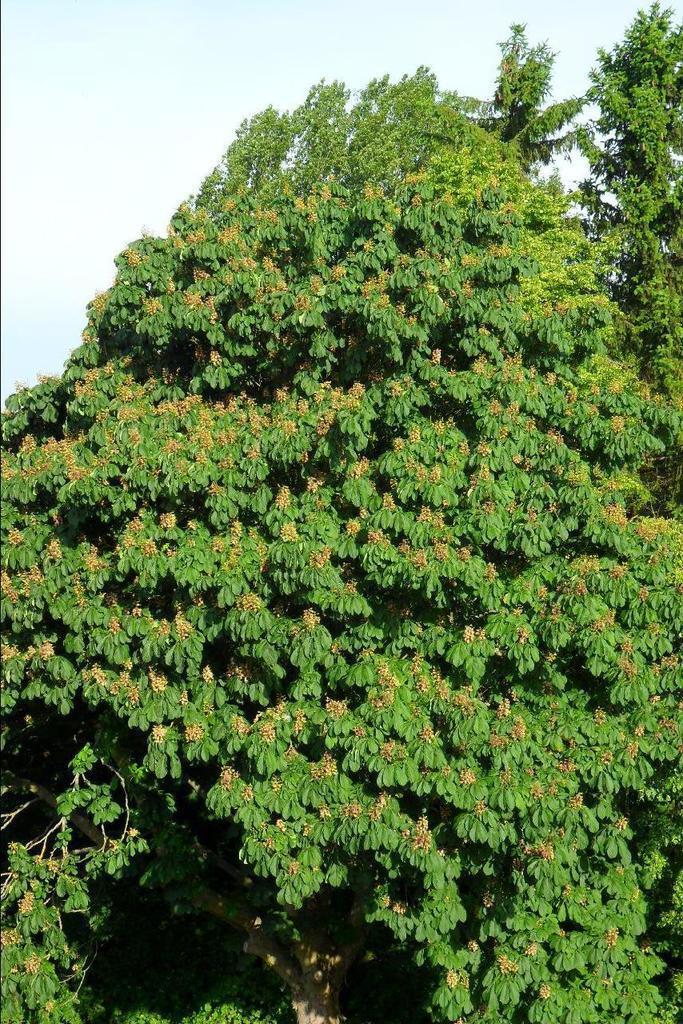Describe this image in one or two sentences. In this image, we can see a tree and at the top, there is a sky. 